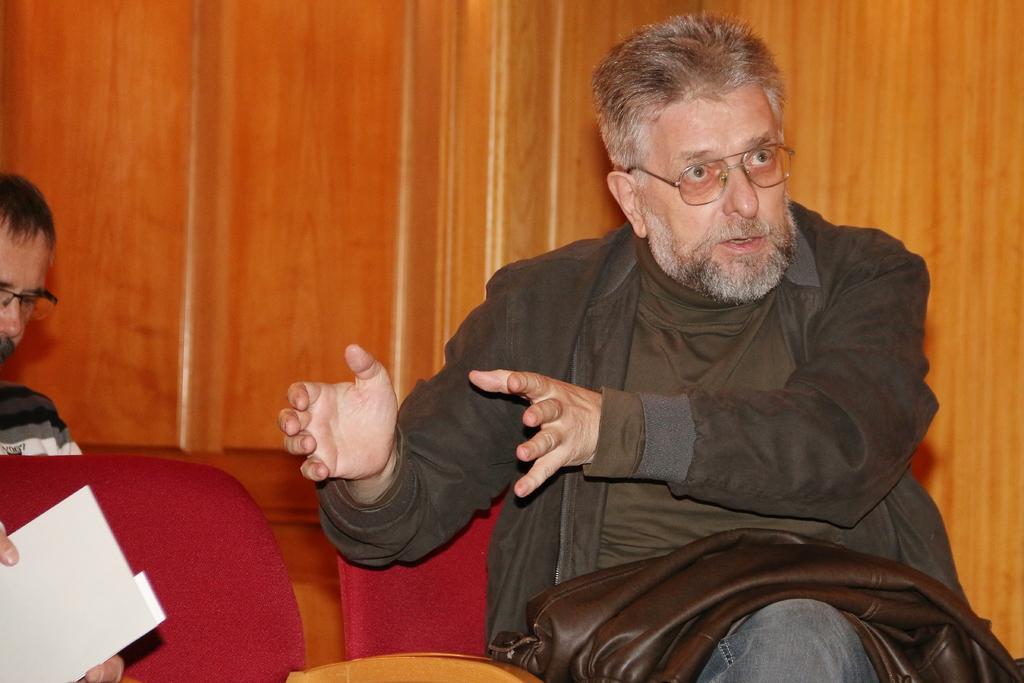Can you describe this image briefly? In this image there is a man sitting on the chair. In the background there is a wooden wall. On the left side there is another person who is also sitting on the chair. On the left side bottom there is a person who is holding the card. 